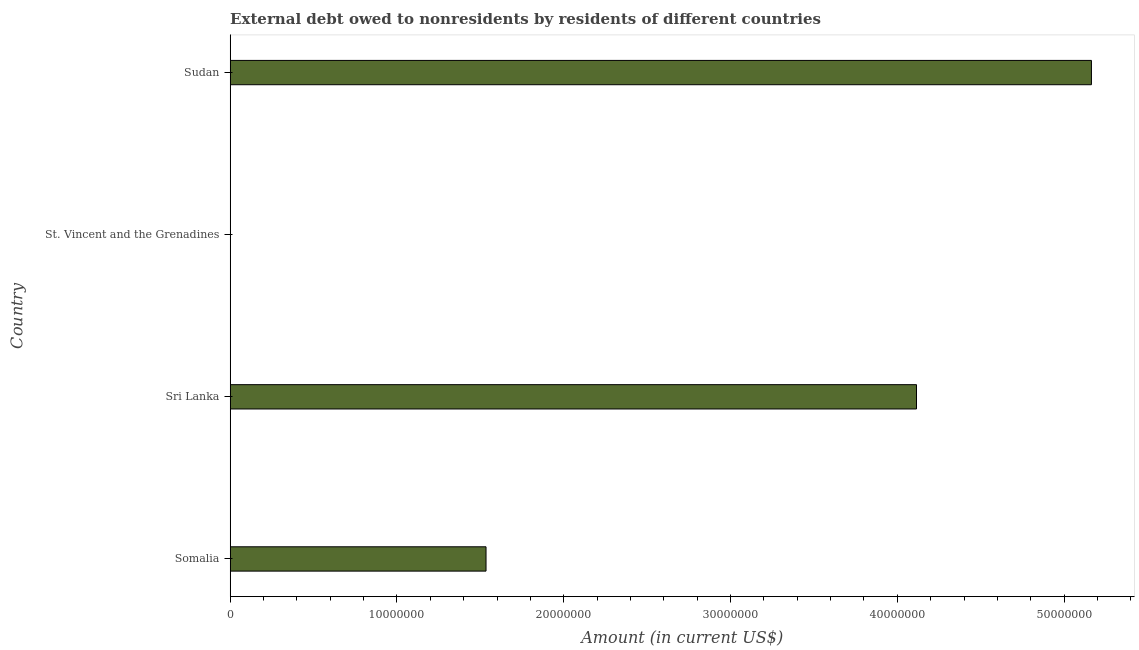Does the graph contain grids?
Offer a very short reply. No. What is the title of the graph?
Give a very brief answer. External debt owed to nonresidents by residents of different countries. What is the label or title of the X-axis?
Keep it short and to the point. Amount (in current US$). What is the debt in Somalia?
Ensure brevity in your answer.  1.53e+07. Across all countries, what is the maximum debt?
Offer a very short reply. 5.16e+07. Across all countries, what is the minimum debt?
Offer a very short reply. 1.50e+04. In which country was the debt maximum?
Offer a very short reply. Sudan. In which country was the debt minimum?
Offer a terse response. St. Vincent and the Grenadines. What is the sum of the debt?
Offer a very short reply. 1.08e+08. What is the difference between the debt in Somalia and St. Vincent and the Grenadines?
Offer a terse response. 1.53e+07. What is the average debt per country?
Provide a succinct answer. 2.70e+07. What is the median debt?
Your answer should be compact. 2.82e+07. In how many countries, is the debt greater than 10000000 US$?
Your response must be concise. 3. What is the ratio of the debt in Sri Lanka to that in St. Vincent and the Grenadines?
Your answer should be very brief. 2743.4. Is the difference between the debt in Somalia and St. Vincent and the Grenadines greater than the difference between any two countries?
Ensure brevity in your answer.  No. What is the difference between the highest and the second highest debt?
Your response must be concise. 1.05e+07. What is the difference between the highest and the lowest debt?
Your response must be concise. 5.16e+07. In how many countries, is the debt greater than the average debt taken over all countries?
Provide a succinct answer. 2. Are all the bars in the graph horizontal?
Ensure brevity in your answer.  Yes. What is the difference between two consecutive major ticks on the X-axis?
Make the answer very short. 1.00e+07. What is the Amount (in current US$) in Somalia?
Your answer should be very brief. 1.53e+07. What is the Amount (in current US$) of Sri Lanka?
Give a very brief answer. 4.12e+07. What is the Amount (in current US$) of St. Vincent and the Grenadines?
Offer a very short reply. 1.50e+04. What is the Amount (in current US$) in Sudan?
Offer a very short reply. 5.16e+07. What is the difference between the Amount (in current US$) in Somalia and Sri Lanka?
Your response must be concise. -2.58e+07. What is the difference between the Amount (in current US$) in Somalia and St. Vincent and the Grenadines?
Give a very brief answer. 1.53e+07. What is the difference between the Amount (in current US$) in Somalia and Sudan?
Give a very brief answer. -3.63e+07. What is the difference between the Amount (in current US$) in Sri Lanka and St. Vincent and the Grenadines?
Offer a very short reply. 4.11e+07. What is the difference between the Amount (in current US$) in Sri Lanka and Sudan?
Your answer should be compact. -1.05e+07. What is the difference between the Amount (in current US$) in St. Vincent and the Grenadines and Sudan?
Ensure brevity in your answer.  -5.16e+07. What is the ratio of the Amount (in current US$) in Somalia to that in Sri Lanka?
Keep it short and to the point. 0.37. What is the ratio of the Amount (in current US$) in Somalia to that in St. Vincent and the Grenadines?
Offer a very short reply. 1022.67. What is the ratio of the Amount (in current US$) in Somalia to that in Sudan?
Ensure brevity in your answer.  0.3. What is the ratio of the Amount (in current US$) in Sri Lanka to that in St. Vincent and the Grenadines?
Your answer should be compact. 2743.4. What is the ratio of the Amount (in current US$) in Sri Lanka to that in Sudan?
Provide a succinct answer. 0.8. 